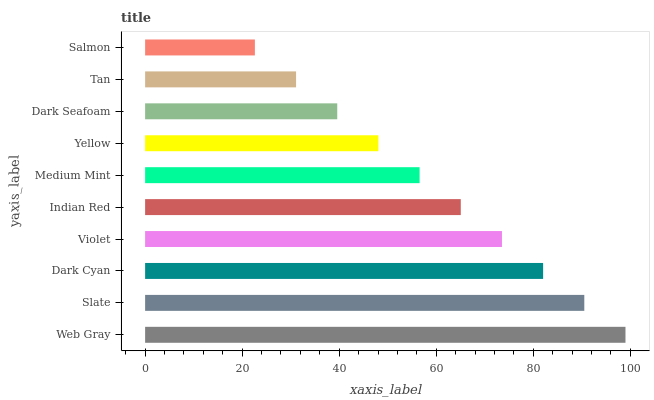Is Salmon the minimum?
Answer yes or no. Yes. Is Web Gray the maximum?
Answer yes or no. Yes. Is Slate the minimum?
Answer yes or no. No. Is Slate the maximum?
Answer yes or no. No. Is Web Gray greater than Slate?
Answer yes or no. Yes. Is Slate less than Web Gray?
Answer yes or no. Yes. Is Slate greater than Web Gray?
Answer yes or no. No. Is Web Gray less than Slate?
Answer yes or no. No. Is Indian Red the high median?
Answer yes or no. Yes. Is Medium Mint the low median?
Answer yes or no. Yes. Is Salmon the high median?
Answer yes or no. No. Is Web Gray the low median?
Answer yes or no. No. 